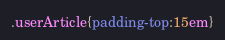<code> <loc_0><loc_0><loc_500><loc_500><_CSS_>.userArticle{padding-top:15em}</code> 